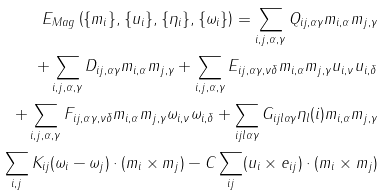Convert formula to latex. <formula><loc_0><loc_0><loc_500><loc_500>E _ { M a g } \left ( \{ { m } _ { i } \} , \{ { u } _ { i } \} , \{ { \eta } _ { i } \} , \{ { \omega } _ { i } \} \right ) = \sum _ { i , j , \alpha , \gamma } Q _ { i j , \alpha \gamma } { m } _ { i , \alpha } { m } _ { j , \gamma } \\ + \sum _ { i , j , \alpha , \gamma } D _ { i j , \alpha \gamma } { m } _ { i , \alpha } { m } _ { j , \gamma } + \sum _ { i , j , \alpha , \gamma } E _ { i j , \alpha \gamma , \nu \delta } { m } _ { i , \alpha } { m } _ { j , \gamma } u _ { i , \nu } u _ { i , \delta } \\ + \sum _ { i , j , \alpha , \gamma } F _ { i j , \alpha \gamma , \nu \delta } { m } _ { i , \alpha } { m } _ { j , \gamma } \omega _ { i , \nu } \omega _ { i , \delta } + \sum _ { i j l \alpha \gamma } G _ { i j l \alpha \gamma } \eta _ { l } ( i ) { m } _ { i , \alpha } { m } _ { j , \gamma } \\ \sum _ { i , j } K _ { i j } ( \omega _ { i } - \omega _ { j } ) \cdot ( { m } _ { i } \times { m } _ { j } ) - C \sum _ { i j } ( { u } _ { i } \times { e _ { i j } } ) \cdot ( { m } _ { i } \times { m } _ { j } )</formula> 